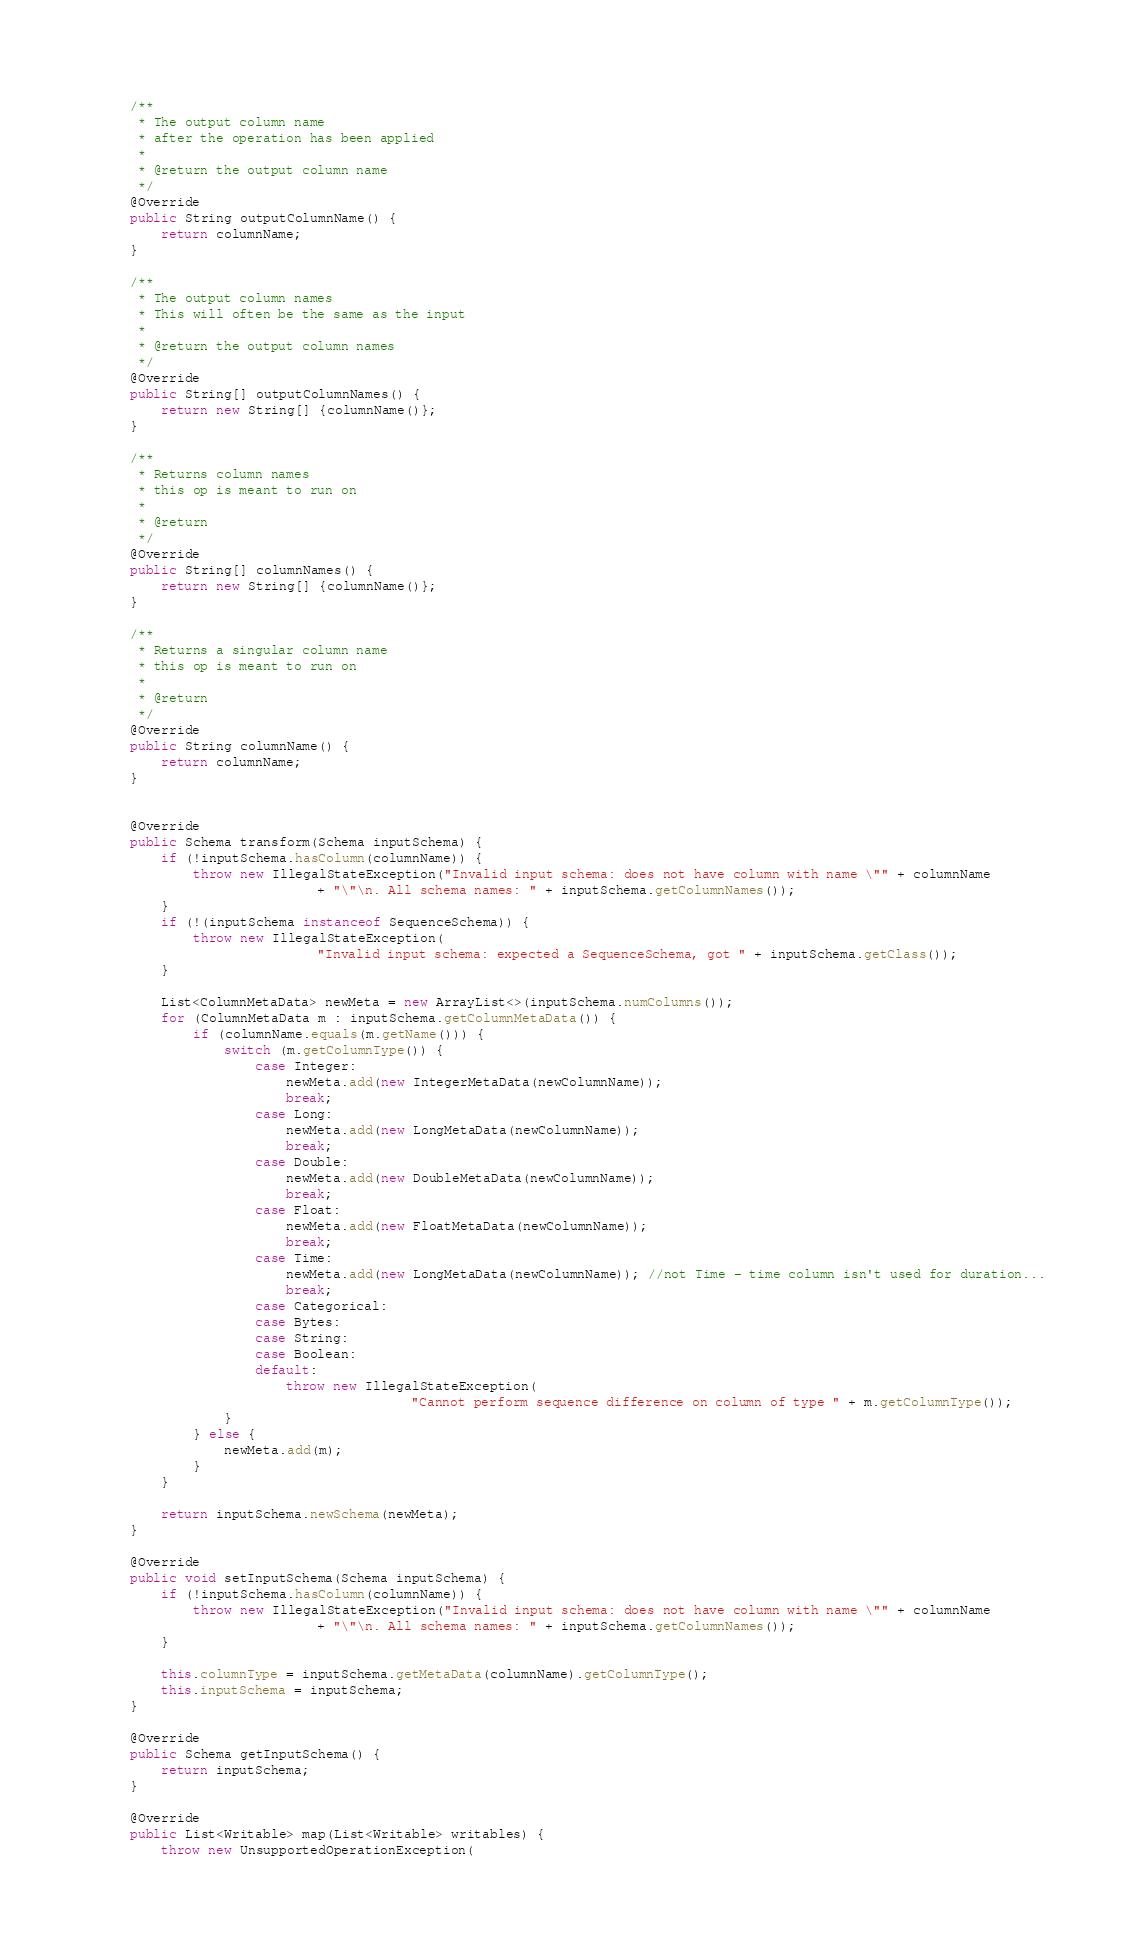Convert code to text. <code><loc_0><loc_0><loc_500><loc_500><_Java_>    /**
     * The output column name
     * after the operation has been applied
     *
     * @return the output column name
     */
    @Override
    public String outputColumnName() {
        return columnName;
    }

    /**
     * The output column names
     * This will often be the same as the input
     *
     * @return the output column names
     */
    @Override
    public String[] outputColumnNames() {
        return new String[] {columnName()};
    }

    /**
     * Returns column names
     * this op is meant to run on
     *
     * @return
     */
    @Override
    public String[] columnNames() {
        return new String[] {columnName()};
    }

    /**
     * Returns a singular column name
     * this op is meant to run on
     *
     * @return
     */
    @Override
    public String columnName() {
        return columnName;
    }


    @Override
    public Schema transform(Schema inputSchema) {
        if (!inputSchema.hasColumn(columnName)) {
            throw new IllegalStateException("Invalid input schema: does not have column with name \"" + columnName
                            + "\"\n. All schema names: " + inputSchema.getColumnNames());
        }
        if (!(inputSchema instanceof SequenceSchema)) {
            throw new IllegalStateException(
                            "Invalid input schema: expected a SequenceSchema, got " + inputSchema.getClass());
        }

        List<ColumnMetaData> newMeta = new ArrayList<>(inputSchema.numColumns());
        for (ColumnMetaData m : inputSchema.getColumnMetaData()) {
            if (columnName.equals(m.getName())) {
                switch (m.getColumnType()) {
                    case Integer:
                        newMeta.add(new IntegerMetaData(newColumnName));
                        break;
                    case Long:
                        newMeta.add(new LongMetaData(newColumnName));
                        break;
                    case Double:
                        newMeta.add(new DoubleMetaData(newColumnName));
                        break;
                    case Float:
                        newMeta.add(new FloatMetaData(newColumnName));
                        break;
                    case Time:
                        newMeta.add(new LongMetaData(newColumnName)); //not Time - time column isn't used for duration...
                        break;
                    case Categorical:
                    case Bytes:
                    case String:
                    case Boolean:
                    default:
                        throw new IllegalStateException(
                                        "Cannot perform sequence difference on column of type " + m.getColumnType());
                }
            } else {
                newMeta.add(m);
            }
        }

        return inputSchema.newSchema(newMeta);
    }

    @Override
    public void setInputSchema(Schema inputSchema) {
        if (!inputSchema.hasColumn(columnName)) {
            throw new IllegalStateException("Invalid input schema: does not have column with name \"" + columnName
                            + "\"\n. All schema names: " + inputSchema.getColumnNames());
        }

        this.columnType = inputSchema.getMetaData(columnName).getColumnType();
        this.inputSchema = inputSchema;
    }

    @Override
    public Schema getInputSchema() {
        return inputSchema;
    }

    @Override
    public List<Writable> map(List<Writable> writables) {
        throw new UnsupportedOperationException(</code> 